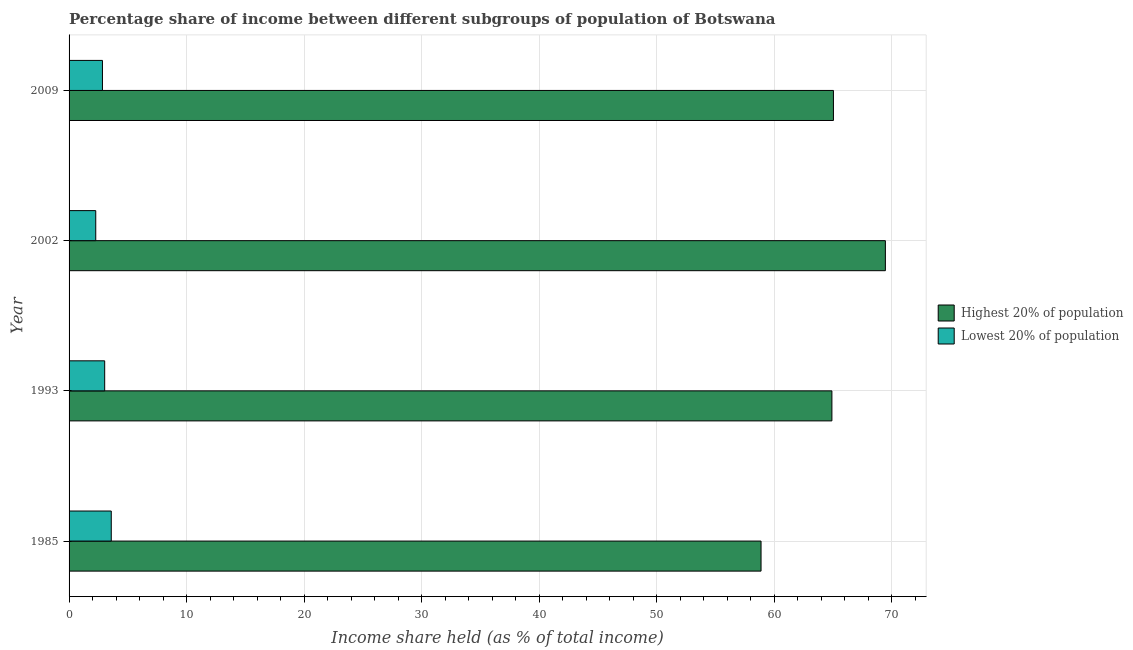How many different coloured bars are there?
Ensure brevity in your answer.  2. How many groups of bars are there?
Keep it short and to the point. 4. How many bars are there on the 1st tick from the top?
Make the answer very short. 2. How many bars are there on the 2nd tick from the bottom?
Offer a very short reply. 2. What is the income share held by highest 20% of the population in 2002?
Offer a terse response. 69.46. Across all years, what is the maximum income share held by lowest 20% of the population?
Offer a very short reply. 3.59. Across all years, what is the minimum income share held by lowest 20% of the population?
Your answer should be very brief. 2.27. What is the total income share held by highest 20% of the population in the graph?
Your answer should be very brief. 258.29. What is the difference between the income share held by highest 20% of the population in 1985 and that in 2009?
Provide a succinct answer. -6.16. What is the difference between the income share held by lowest 20% of the population in 2009 and the income share held by highest 20% of the population in 1993?
Offer a very short reply. -62.07. What is the average income share held by highest 20% of the population per year?
Give a very brief answer. 64.57. In the year 2002, what is the difference between the income share held by highest 20% of the population and income share held by lowest 20% of the population?
Your answer should be very brief. 67.19. What is the ratio of the income share held by lowest 20% of the population in 2002 to that in 2009?
Provide a succinct answer. 0.8. Is the difference between the income share held by highest 20% of the population in 1993 and 2009 greater than the difference between the income share held by lowest 20% of the population in 1993 and 2009?
Keep it short and to the point. No. What is the difference between the highest and the second highest income share held by lowest 20% of the population?
Keep it short and to the point. 0.56. What is the difference between the highest and the lowest income share held by highest 20% of the population?
Provide a short and direct response. 10.58. In how many years, is the income share held by highest 20% of the population greater than the average income share held by highest 20% of the population taken over all years?
Offer a very short reply. 3. Is the sum of the income share held by lowest 20% of the population in 1993 and 2009 greater than the maximum income share held by highest 20% of the population across all years?
Ensure brevity in your answer.  No. What does the 2nd bar from the top in 1985 represents?
Provide a succinct answer. Highest 20% of population. What does the 2nd bar from the bottom in 1985 represents?
Give a very brief answer. Lowest 20% of population. Are all the bars in the graph horizontal?
Your response must be concise. Yes. How many years are there in the graph?
Provide a short and direct response. 4. What is the difference between two consecutive major ticks on the X-axis?
Provide a succinct answer. 10. Are the values on the major ticks of X-axis written in scientific E-notation?
Give a very brief answer. No. Where does the legend appear in the graph?
Give a very brief answer. Center right. How many legend labels are there?
Provide a succinct answer. 2. How are the legend labels stacked?
Your response must be concise. Vertical. What is the title of the graph?
Keep it short and to the point. Percentage share of income between different subgroups of population of Botswana. Does "By country of origin" appear as one of the legend labels in the graph?
Your answer should be very brief. No. What is the label or title of the X-axis?
Offer a very short reply. Income share held (as % of total income). What is the Income share held (as % of total income) in Highest 20% of population in 1985?
Provide a succinct answer. 58.88. What is the Income share held (as % of total income) in Lowest 20% of population in 1985?
Your response must be concise. 3.59. What is the Income share held (as % of total income) of Highest 20% of population in 1993?
Your response must be concise. 64.91. What is the Income share held (as % of total income) in Lowest 20% of population in 1993?
Keep it short and to the point. 3.03. What is the Income share held (as % of total income) of Highest 20% of population in 2002?
Provide a succinct answer. 69.46. What is the Income share held (as % of total income) in Lowest 20% of population in 2002?
Your answer should be very brief. 2.27. What is the Income share held (as % of total income) of Highest 20% of population in 2009?
Provide a short and direct response. 65.04. What is the Income share held (as % of total income) in Lowest 20% of population in 2009?
Your answer should be compact. 2.84. Across all years, what is the maximum Income share held (as % of total income) of Highest 20% of population?
Provide a short and direct response. 69.46. Across all years, what is the maximum Income share held (as % of total income) in Lowest 20% of population?
Provide a succinct answer. 3.59. Across all years, what is the minimum Income share held (as % of total income) in Highest 20% of population?
Provide a succinct answer. 58.88. Across all years, what is the minimum Income share held (as % of total income) of Lowest 20% of population?
Keep it short and to the point. 2.27. What is the total Income share held (as % of total income) in Highest 20% of population in the graph?
Provide a short and direct response. 258.29. What is the total Income share held (as % of total income) in Lowest 20% of population in the graph?
Ensure brevity in your answer.  11.73. What is the difference between the Income share held (as % of total income) in Highest 20% of population in 1985 and that in 1993?
Your answer should be very brief. -6.03. What is the difference between the Income share held (as % of total income) in Lowest 20% of population in 1985 and that in 1993?
Provide a succinct answer. 0.56. What is the difference between the Income share held (as % of total income) of Highest 20% of population in 1985 and that in 2002?
Make the answer very short. -10.58. What is the difference between the Income share held (as % of total income) of Lowest 20% of population in 1985 and that in 2002?
Your response must be concise. 1.32. What is the difference between the Income share held (as % of total income) of Highest 20% of population in 1985 and that in 2009?
Offer a terse response. -6.16. What is the difference between the Income share held (as % of total income) of Highest 20% of population in 1993 and that in 2002?
Offer a terse response. -4.55. What is the difference between the Income share held (as % of total income) in Lowest 20% of population in 1993 and that in 2002?
Your response must be concise. 0.76. What is the difference between the Income share held (as % of total income) in Highest 20% of population in 1993 and that in 2009?
Give a very brief answer. -0.13. What is the difference between the Income share held (as % of total income) of Lowest 20% of population in 1993 and that in 2009?
Provide a succinct answer. 0.19. What is the difference between the Income share held (as % of total income) in Highest 20% of population in 2002 and that in 2009?
Provide a short and direct response. 4.42. What is the difference between the Income share held (as % of total income) in Lowest 20% of population in 2002 and that in 2009?
Your answer should be very brief. -0.57. What is the difference between the Income share held (as % of total income) of Highest 20% of population in 1985 and the Income share held (as % of total income) of Lowest 20% of population in 1993?
Offer a terse response. 55.85. What is the difference between the Income share held (as % of total income) in Highest 20% of population in 1985 and the Income share held (as % of total income) in Lowest 20% of population in 2002?
Your answer should be very brief. 56.61. What is the difference between the Income share held (as % of total income) in Highest 20% of population in 1985 and the Income share held (as % of total income) in Lowest 20% of population in 2009?
Provide a short and direct response. 56.04. What is the difference between the Income share held (as % of total income) of Highest 20% of population in 1993 and the Income share held (as % of total income) of Lowest 20% of population in 2002?
Ensure brevity in your answer.  62.64. What is the difference between the Income share held (as % of total income) of Highest 20% of population in 1993 and the Income share held (as % of total income) of Lowest 20% of population in 2009?
Keep it short and to the point. 62.07. What is the difference between the Income share held (as % of total income) in Highest 20% of population in 2002 and the Income share held (as % of total income) in Lowest 20% of population in 2009?
Offer a terse response. 66.62. What is the average Income share held (as % of total income) of Highest 20% of population per year?
Offer a very short reply. 64.57. What is the average Income share held (as % of total income) in Lowest 20% of population per year?
Make the answer very short. 2.93. In the year 1985, what is the difference between the Income share held (as % of total income) of Highest 20% of population and Income share held (as % of total income) of Lowest 20% of population?
Your response must be concise. 55.29. In the year 1993, what is the difference between the Income share held (as % of total income) of Highest 20% of population and Income share held (as % of total income) of Lowest 20% of population?
Your answer should be very brief. 61.88. In the year 2002, what is the difference between the Income share held (as % of total income) of Highest 20% of population and Income share held (as % of total income) of Lowest 20% of population?
Ensure brevity in your answer.  67.19. In the year 2009, what is the difference between the Income share held (as % of total income) in Highest 20% of population and Income share held (as % of total income) in Lowest 20% of population?
Keep it short and to the point. 62.2. What is the ratio of the Income share held (as % of total income) of Highest 20% of population in 1985 to that in 1993?
Keep it short and to the point. 0.91. What is the ratio of the Income share held (as % of total income) of Lowest 20% of population in 1985 to that in 1993?
Your response must be concise. 1.18. What is the ratio of the Income share held (as % of total income) in Highest 20% of population in 1985 to that in 2002?
Your answer should be compact. 0.85. What is the ratio of the Income share held (as % of total income) of Lowest 20% of population in 1985 to that in 2002?
Offer a terse response. 1.58. What is the ratio of the Income share held (as % of total income) in Highest 20% of population in 1985 to that in 2009?
Offer a very short reply. 0.91. What is the ratio of the Income share held (as % of total income) in Lowest 20% of population in 1985 to that in 2009?
Give a very brief answer. 1.26. What is the ratio of the Income share held (as % of total income) of Highest 20% of population in 1993 to that in 2002?
Provide a succinct answer. 0.93. What is the ratio of the Income share held (as % of total income) in Lowest 20% of population in 1993 to that in 2002?
Your answer should be very brief. 1.33. What is the ratio of the Income share held (as % of total income) of Highest 20% of population in 1993 to that in 2009?
Provide a short and direct response. 1. What is the ratio of the Income share held (as % of total income) in Lowest 20% of population in 1993 to that in 2009?
Provide a succinct answer. 1.07. What is the ratio of the Income share held (as % of total income) in Highest 20% of population in 2002 to that in 2009?
Offer a terse response. 1.07. What is the ratio of the Income share held (as % of total income) of Lowest 20% of population in 2002 to that in 2009?
Offer a very short reply. 0.8. What is the difference between the highest and the second highest Income share held (as % of total income) of Highest 20% of population?
Your answer should be very brief. 4.42. What is the difference between the highest and the second highest Income share held (as % of total income) of Lowest 20% of population?
Your answer should be compact. 0.56. What is the difference between the highest and the lowest Income share held (as % of total income) of Highest 20% of population?
Keep it short and to the point. 10.58. What is the difference between the highest and the lowest Income share held (as % of total income) in Lowest 20% of population?
Make the answer very short. 1.32. 